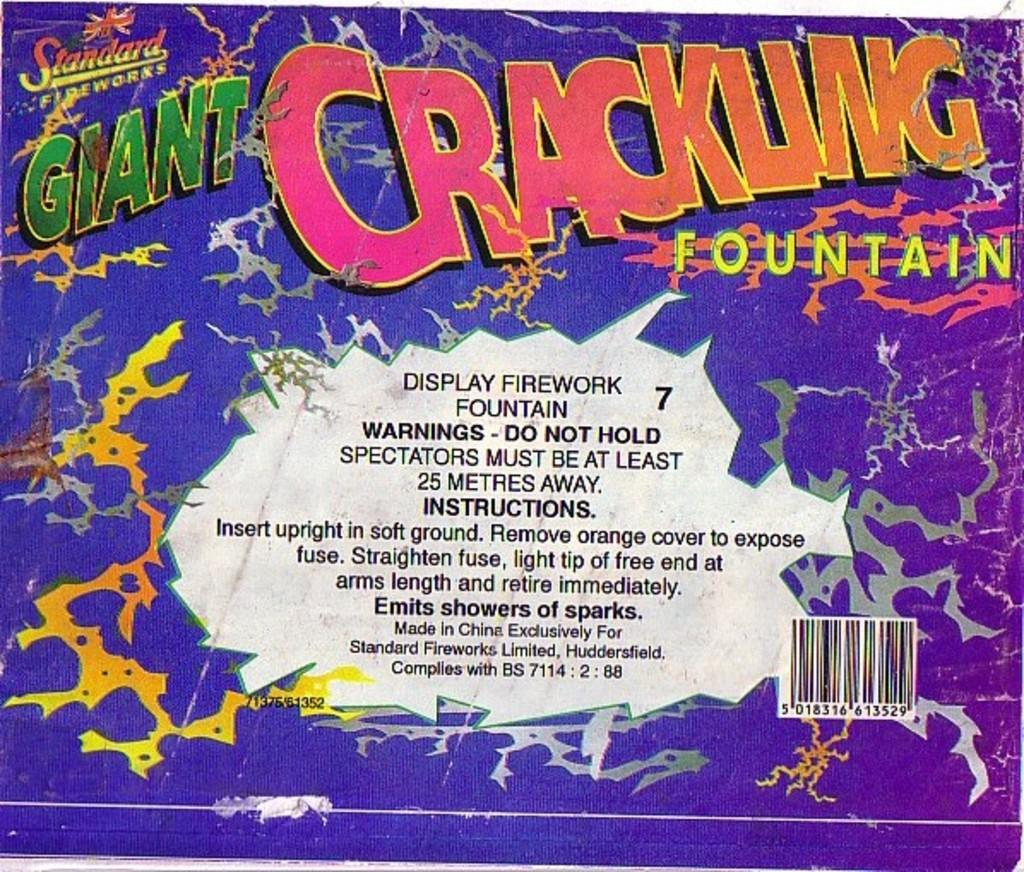Provide a one-sentence caption for the provided image. The firework packaging displayed a lot of useful information. 